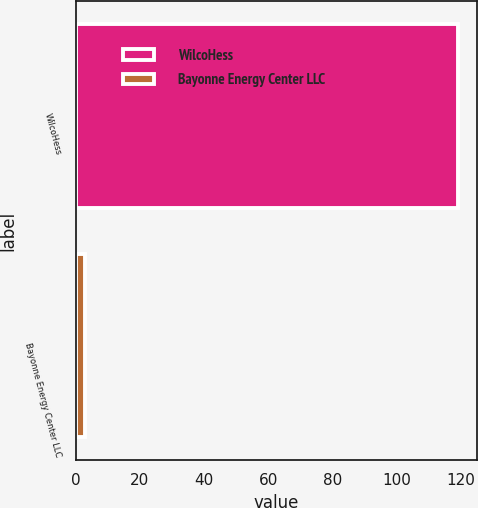Convert chart. <chart><loc_0><loc_0><loc_500><loc_500><bar_chart><fcel>WilcoHess<fcel>Bayonne Energy Center LLC<nl><fcel>119<fcel>3<nl></chart> 